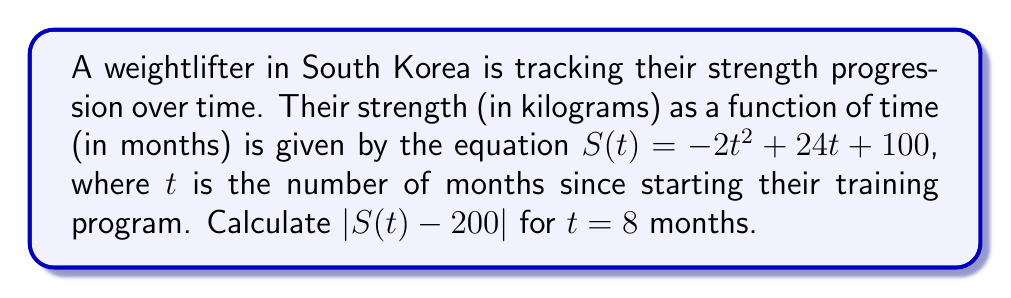Give your solution to this math problem. To solve this problem, we'll follow these steps:

1) First, we need to calculate $S(8)$, which is the strength at 8 months:

   $S(8) = -2(8)^2 + 24(8) + 100$
   $= -2(64) + 192 + 100$
   $= -128 + 192 + 100$
   $= 164$ kg

2) Now, we need to calculate $S(8) - 200$:

   $164 - 200 = -36$

3) Finally, we need to take the absolute value of this result:

   $|S(8) - 200| = |-36| = 36$

The absolute value transformation $|S(t) - 200|$ represents the distance between the weightlifter's strength and 200 kg at any given time. In this case, at 8 months, the weightlifter's strength is 36 kg away from 200 kg (specifically, 36 kg below 200 kg).
Answer: $|S(8) - 200| = 36$ kg 